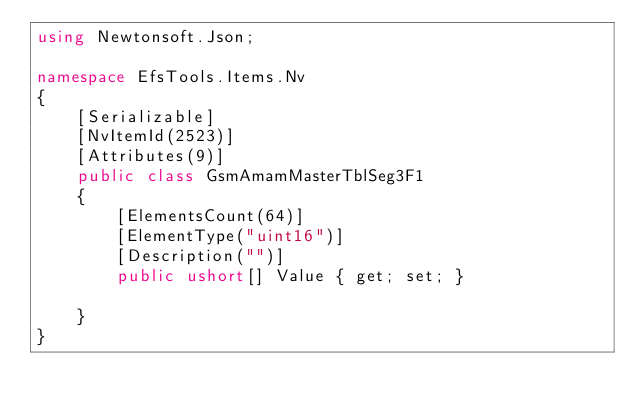<code> <loc_0><loc_0><loc_500><loc_500><_C#_>using Newtonsoft.Json;

namespace EfsTools.Items.Nv
{
    [Serializable]
    [NvItemId(2523)]
    [Attributes(9)]
    public class GsmAmamMasterTblSeg3F1
    {
        [ElementsCount(64)]
        [ElementType("uint16")]
        [Description("")]
        public ushort[] Value { get; set; }
        
    }
}
</code> 